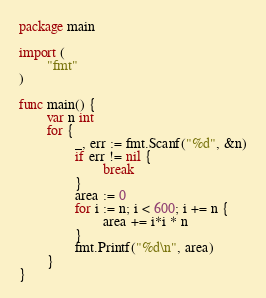Convert code to text. <code><loc_0><loc_0><loc_500><loc_500><_Go_>package main

import (
        "fmt"
)

func main() {
        var n int
        for {
                _, err := fmt.Scanf("%d", &n)
                if err != nil {
                        break
                }
                area := 0
                for i := n; i < 600; i += n {
                        area += i*i * n
                }
                fmt.Printf("%d\n", area)
        }
}

</code> 